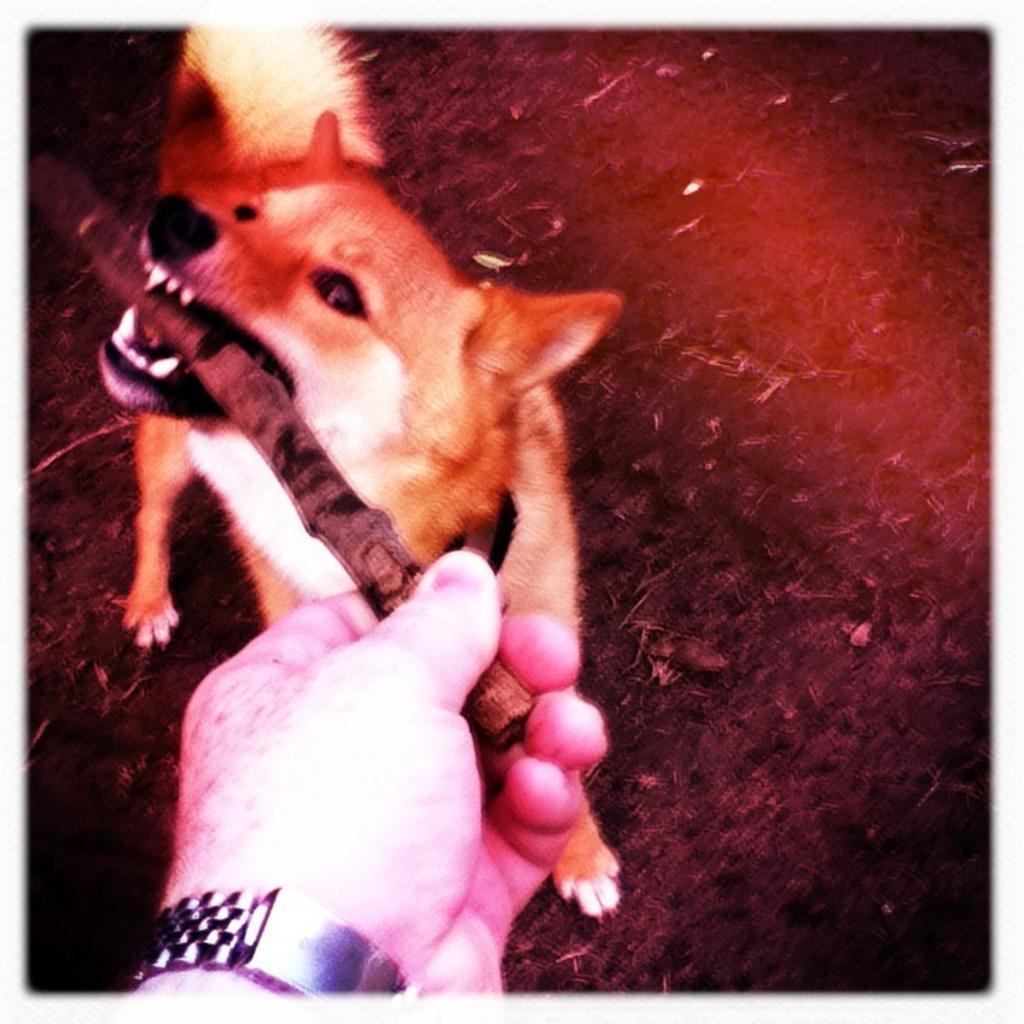Could you give a brief overview of what you see in this image? In this image there is a dog. At the bottom we can see a person's hand holding a stick. 